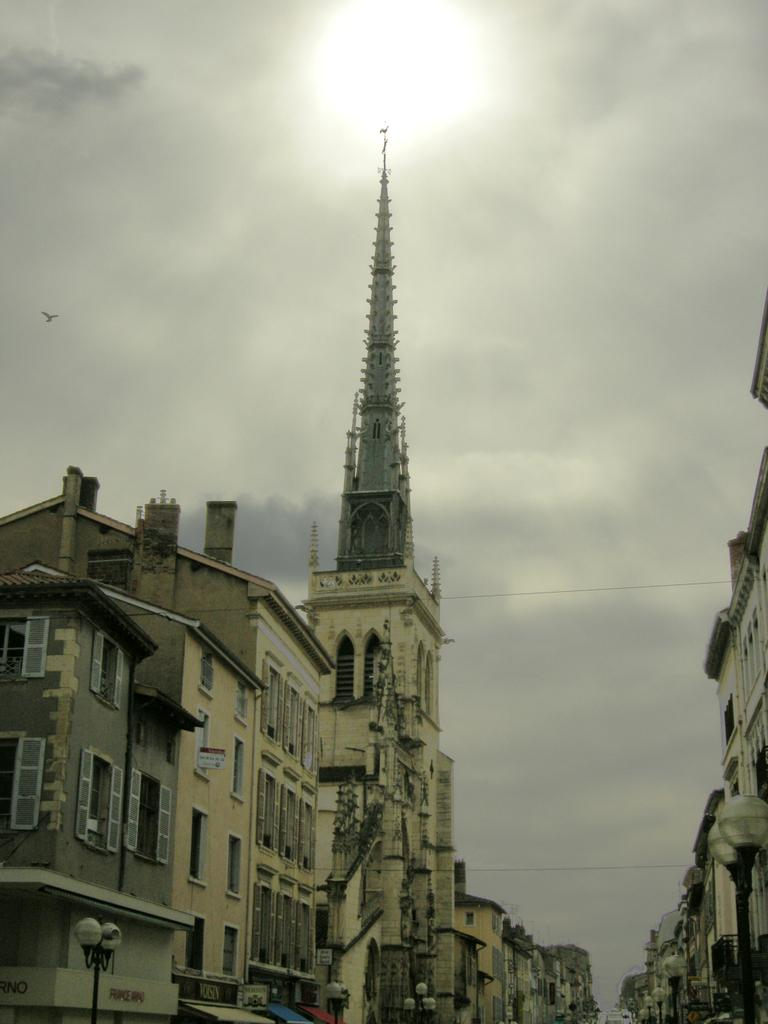What type of structures can be seen in the image? There are buildings, light poles, and a tower in the image. What is happening in the sky in the image? There is a cloudy sky in the background of the image, and the sun is visible. Can you describe any living creatures in the image? Yes, a bird is flying in the image. What type of spoon is being used by the governor in the image? There is no governor or spoon present in the image. What type of skin condition can be seen on the bird in the image? There is no indication of a skin condition on the bird in the image, as it is flying and not close enough for such a detail to be observed. 